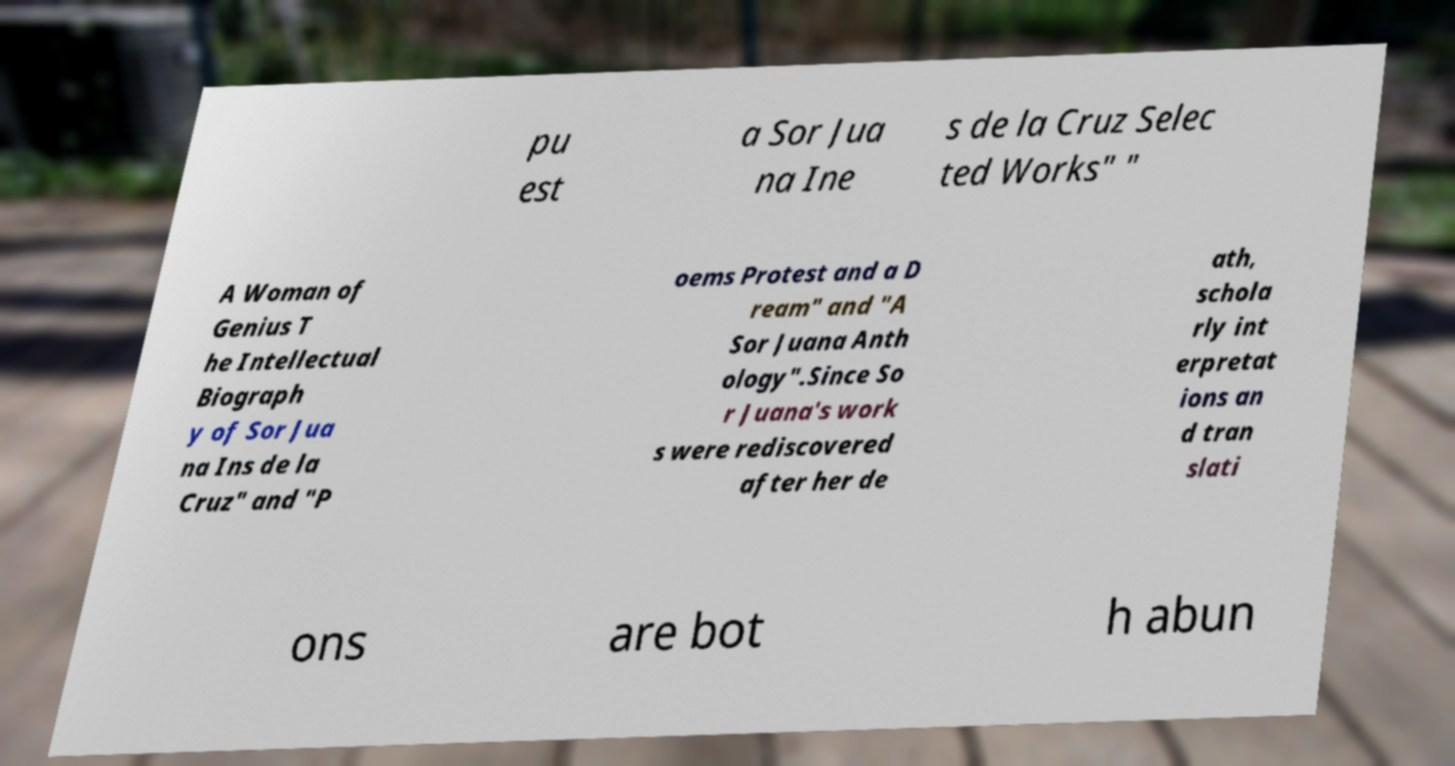There's text embedded in this image that I need extracted. Can you transcribe it verbatim? pu est a Sor Jua na Ine s de la Cruz Selec ted Works" " A Woman of Genius T he Intellectual Biograph y of Sor Jua na Ins de la Cruz" and "P oems Protest and a D ream" and "A Sor Juana Anth ology".Since So r Juana's work s were rediscovered after her de ath, schola rly int erpretat ions an d tran slati ons are bot h abun 